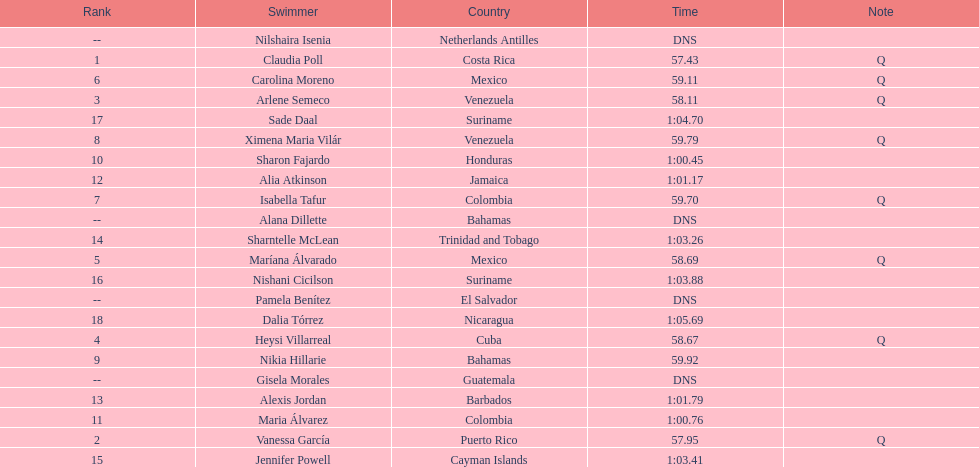What swimmer had the top or first rank? Claudia Poll. 